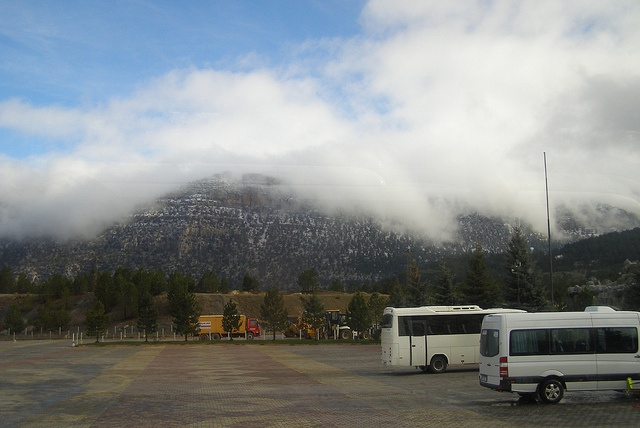Describe the objects in this image and their specific colors. I can see bus in darkgray, black, and gray tones, bus in darkgray, black, and gray tones, and truck in darkgray, olive, black, and maroon tones in this image. 